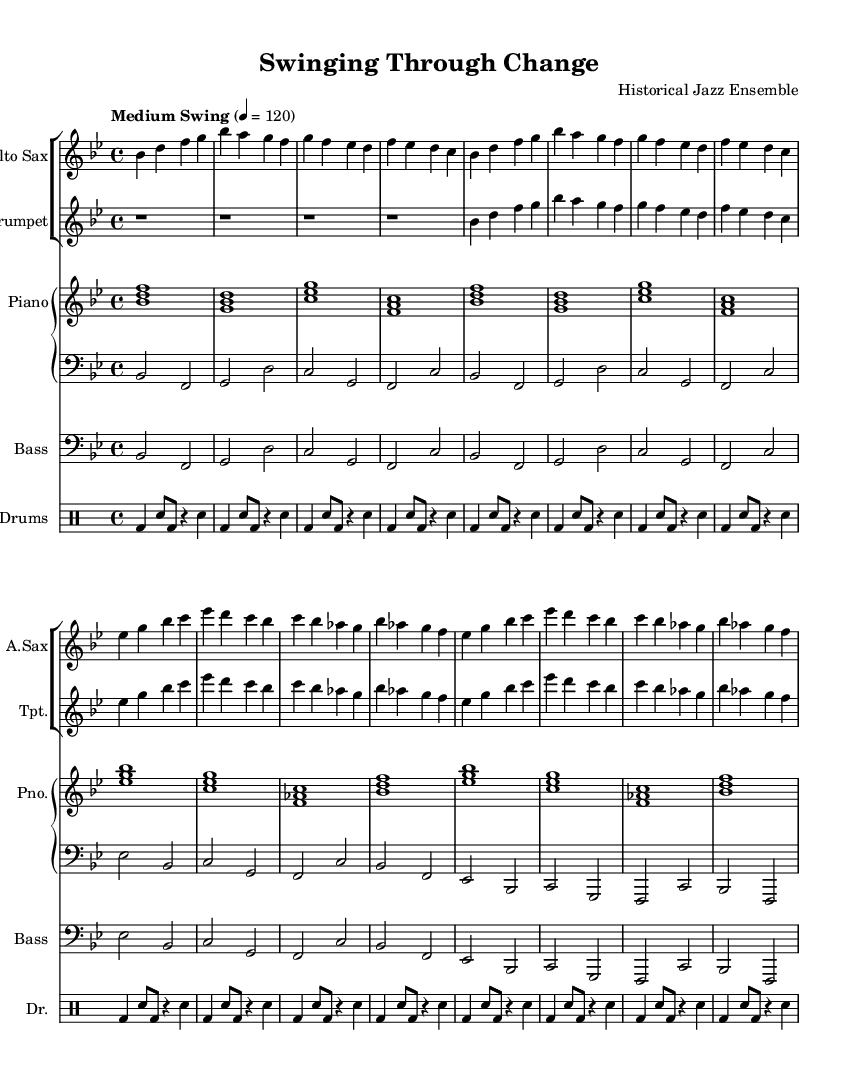What is the key signature of this music? The key signature is indicated at the beginning of the music, showing two flats. This corresponds to B flat major.
Answer: B flat major What is the time signature of the piece? The time signature is found at the beginning of the score, where it shows a 4 over 4, indicating that there are four beats per measure.
Answer: 4/4 What is the tempo marking for this piece? The tempo marking is written above the staff indicating a "Medium Swing" with a metronome marking of 120 beats per minute.
Answer: Medium Swing How many measures are there in the saxophone part? By examining the notation for the saxophone part, we can count the number of measures it contains. Counting the measures, there are 16 measures in the saxophone part.
Answer: 16 What is the rhythmic pattern used in the drum part? The drum part includes a repeated rhythmic motif consisting of a bass drum hit followed by snare drum hits interspersed with rests, commonly found in swing music. The pattern indicates a driving rhythm often used in swing styles.
Answer: Bass and snare pattern How many instruments are featured in this arrangement? Looking at the score, there are five distinct parts: alto saxophone, trumpet, piano (with right and left hand parts), bass, and drums. Thus, the arrangement features five instruments.
Answer: Five instruments What is the significance of the swing feel in this era of music? The "swing" feel is characterized by a rhythmic drive and flow, reflecting the social changes of the 1930s and 1940s, where jazz became a popular form of expression and mirrored the optimism and energy of the era.
Answer: Reflects optimism and energy 